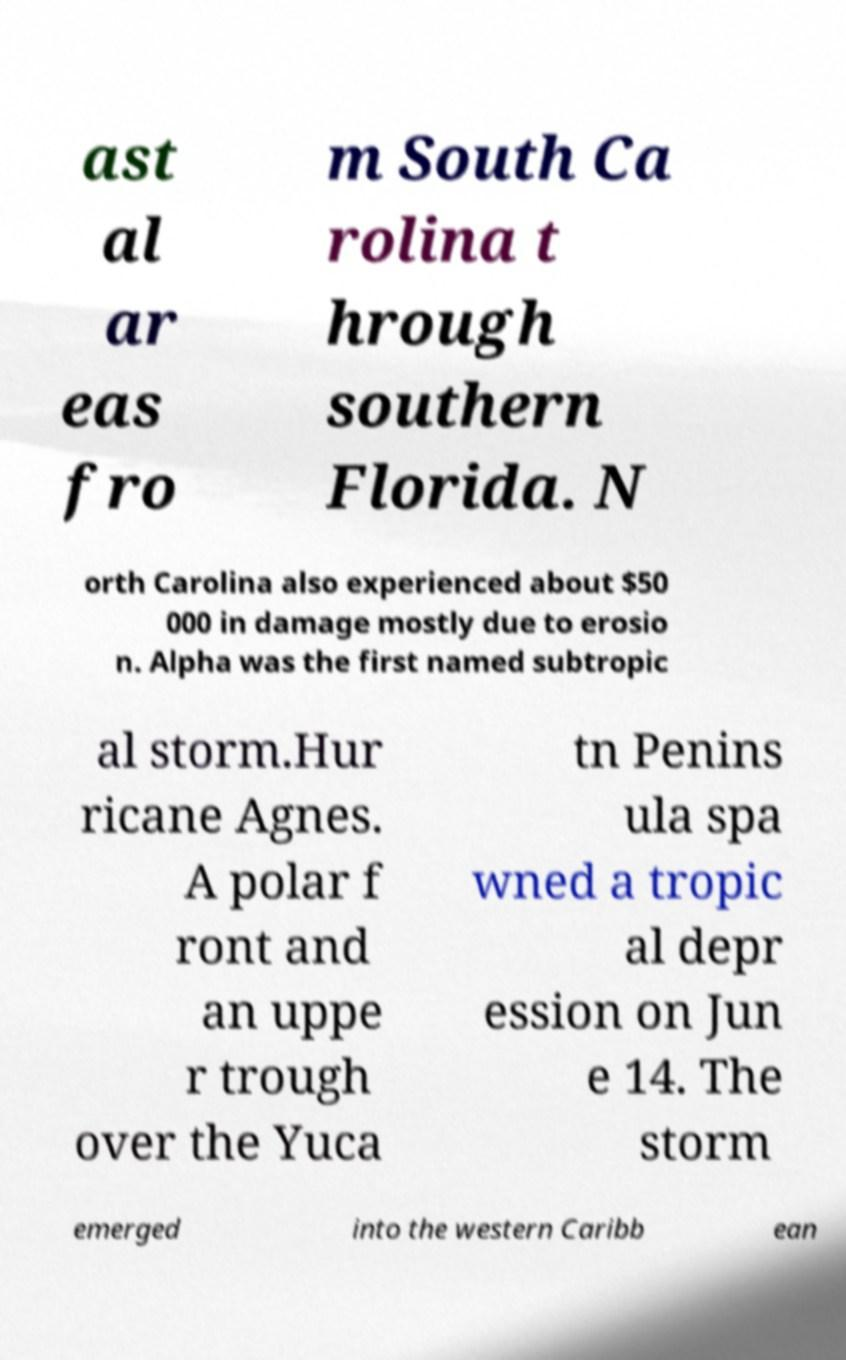I need the written content from this picture converted into text. Can you do that? ast al ar eas fro m South Ca rolina t hrough southern Florida. N orth Carolina also experienced about $50 000 in damage mostly due to erosio n. Alpha was the first named subtropic al storm.Hur ricane Agnes. A polar f ront and an uppe r trough over the Yuca tn Penins ula spa wned a tropic al depr ession on Jun e 14. The storm emerged into the western Caribb ean 